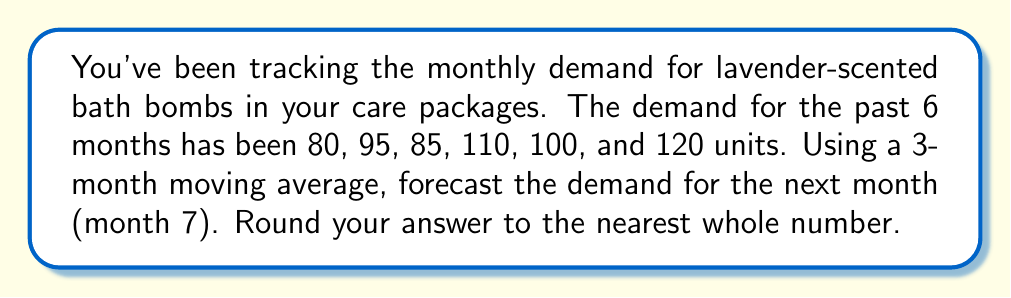Give your solution to this math problem. To solve this problem, we'll use the 3-month moving average method:

1. First, let's organize our data:
   Month 1: 80
   Month 2: 95
   Month 3: 85
   Month 4: 110
   Month 5: 100
   Month 6: 120

2. The 3-month moving average is calculated by taking the average of the most recent 3 months of data. We'll use this to forecast the next month.

3. To forecast month 7, we'll use the data from months 4, 5, and 6:

   $$ \text{Forecast for Month 7} = \frac{\text{Month 4 + Month 5 + Month 6}}{3} $$

4. Let's plug in the numbers:

   $$ \text{Forecast for Month 7} = \frac{110 + 100 + 120}{3} $$

5. Simplify:

   $$ \text{Forecast for Month 7} = \frac{330}{3} = 110 $$

6. The result is already a whole number, so no rounding is necessary.
Answer: 110 units 